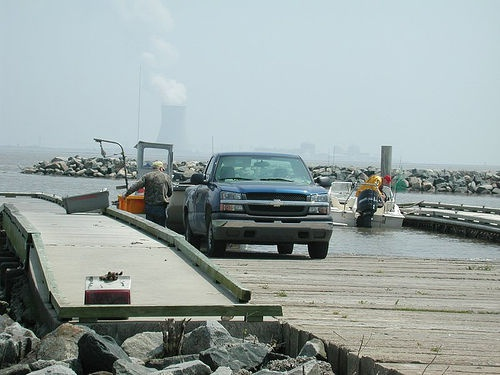Describe the objects in this image and their specific colors. I can see truck in lightblue, black, gray, and darkgray tones, boat in lightblue, darkgray, gray, black, and lightgray tones, people in lightblue, black, gray, and darkgray tones, and people in lightblue, olive, gray, and tan tones in this image. 